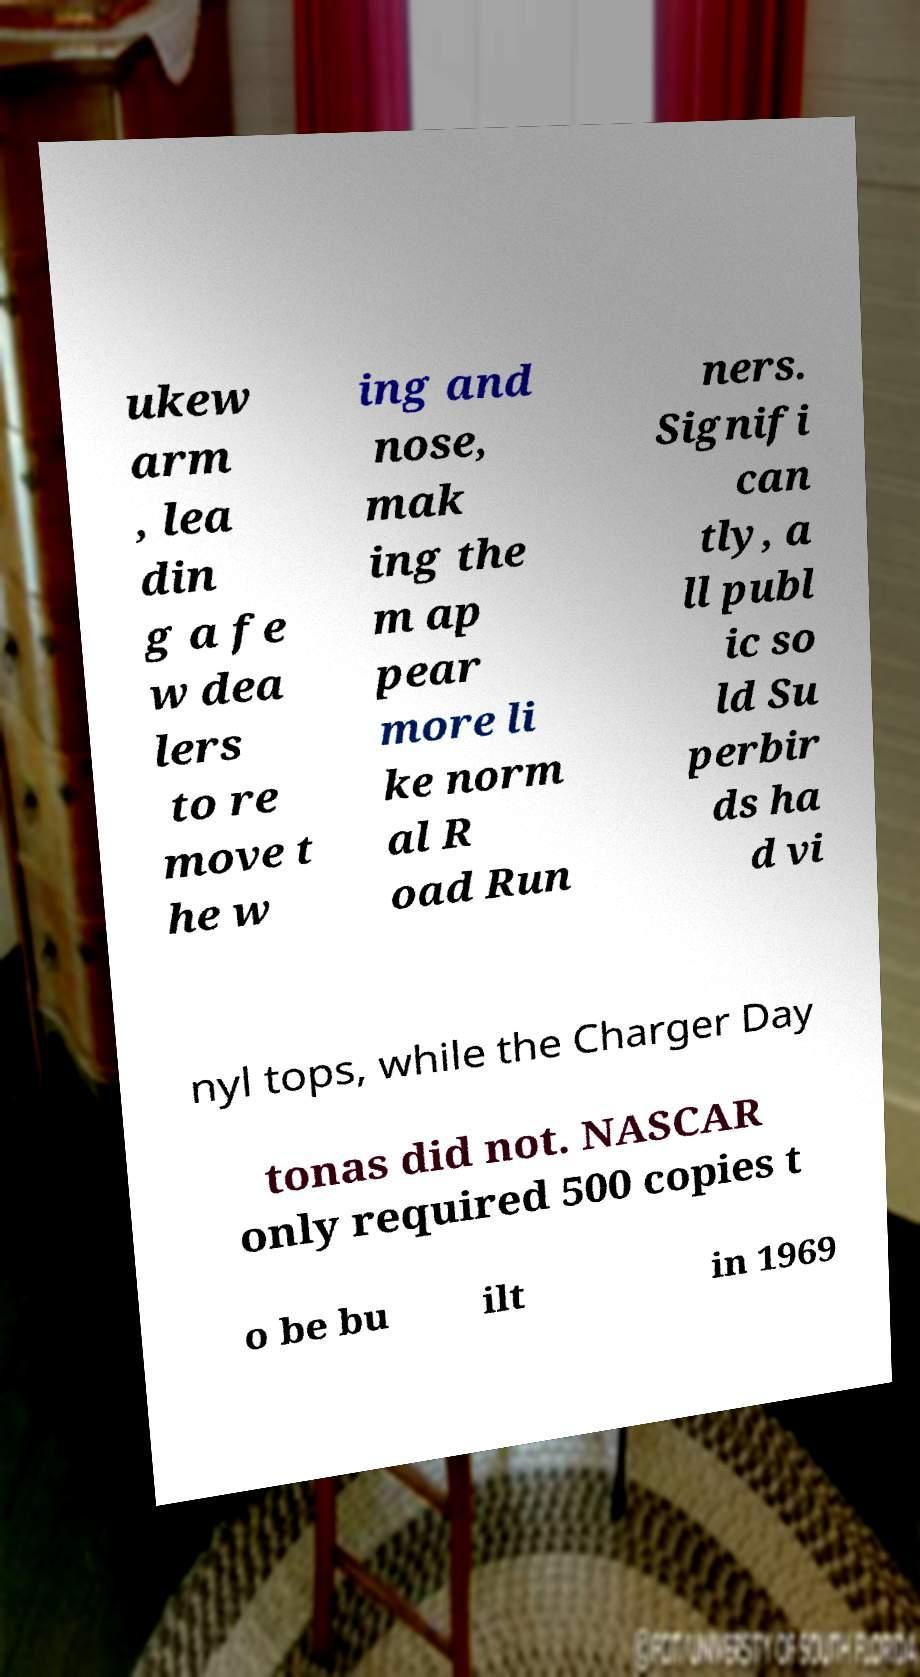Could you assist in decoding the text presented in this image and type it out clearly? ukew arm , lea din g a fe w dea lers to re move t he w ing and nose, mak ing the m ap pear more li ke norm al R oad Run ners. Signifi can tly, a ll publ ic so ld Su perbir ds ha d vi nyl tops, while the Charger Day tonas did not. NASCAR only required 500 copies t o be bu ilt in 1969 